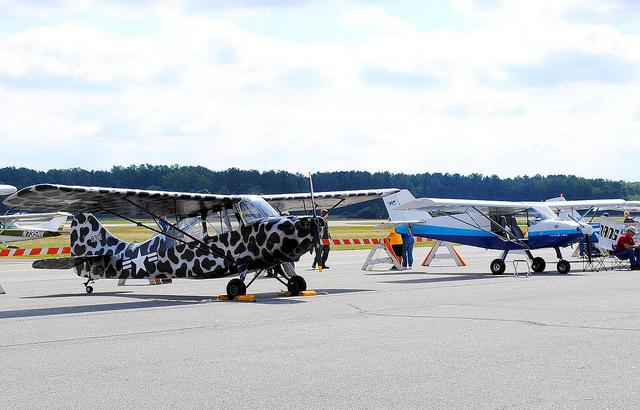What animal mimics the pattern of the plane to the left? Please explain your reasoning. snow leopard. The animal is a leopard. 